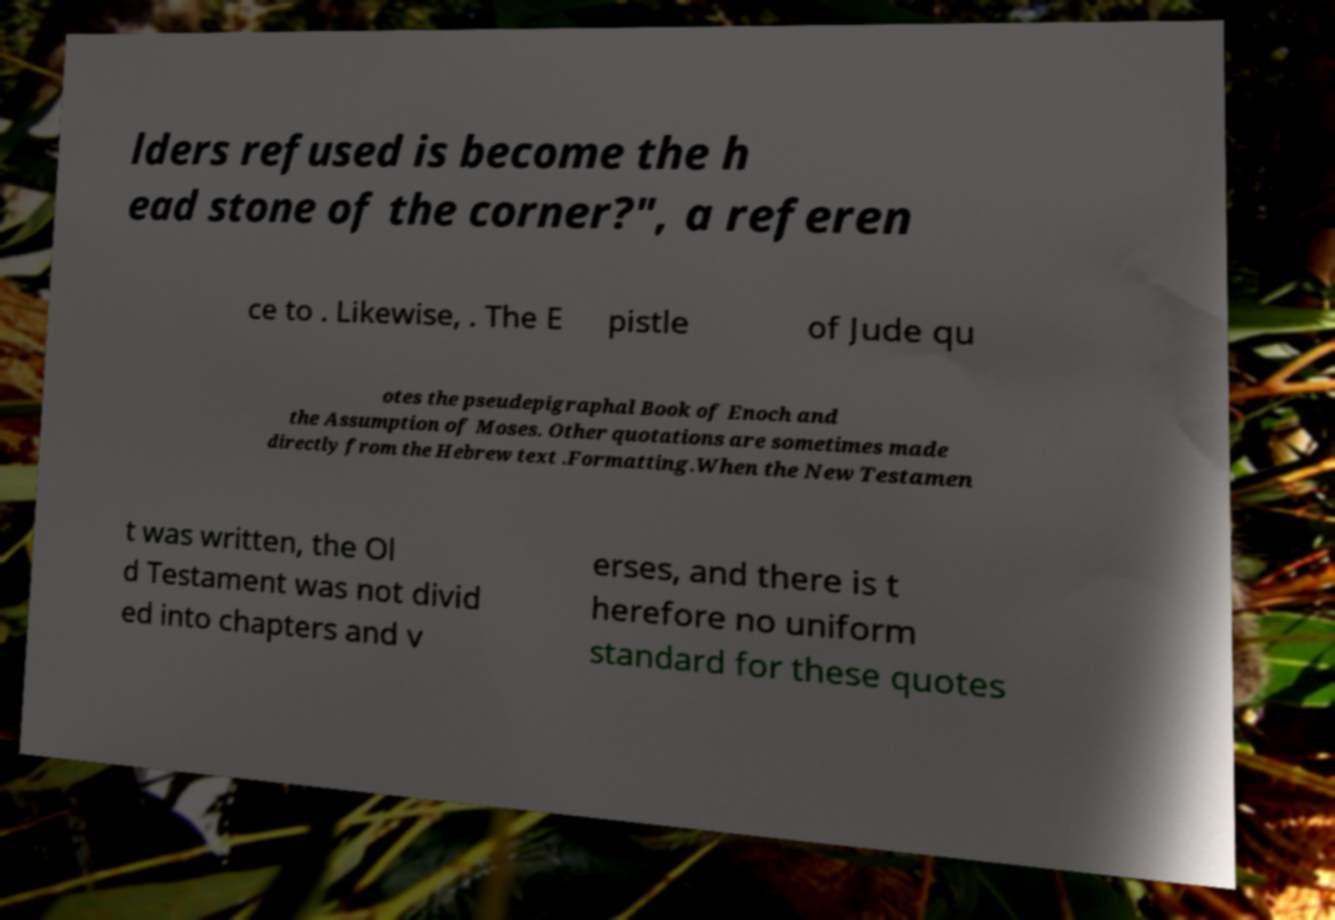Please identify and transcribe the text found in this image. lders refused is become the h ead stone of the corner?", a referen ce to . Likewise, . The E pistle of Jude qu otes the pseudepigraphal Book of Enoch and the Assumption of Moses. Other quotations are sometimes made directly from the Hebrew text .Formatting.When the New Testamen t was written, the Ol d Testament was not divid ed into chapters and v erses, and there is t herefore no uniform standard for these quotes 